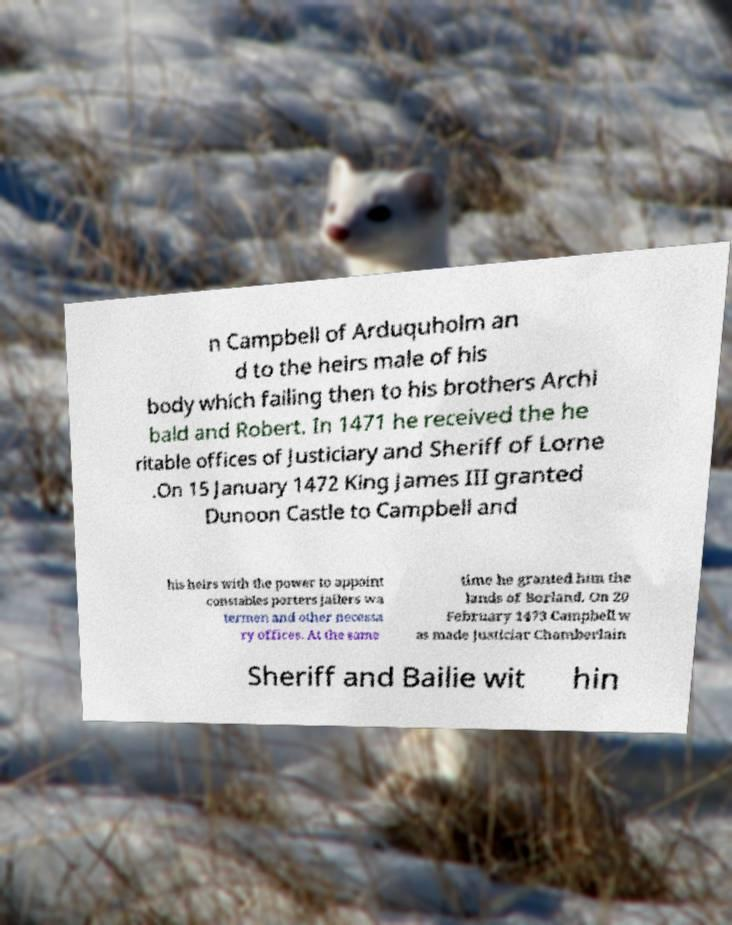Could you extract and type out the text from this image? n Campbell of Arduquholm an d to the heirs male of his body which failing then to his brothers Archi bald and Robert. In 1471 he received the he ritable offices of Justiciary and Sheriff of Lorne .On 15 January 1472 King James III granted Dunoon Castle to Campbell and his heirs with the power to appoint constables porters jailers wa termen and other necessa ry offices. At the same time he granted him the lands of Borland. On 20 February 1473 Campbell w as made Justiciar Chamberlain Sheriff and Bailie wit hin 